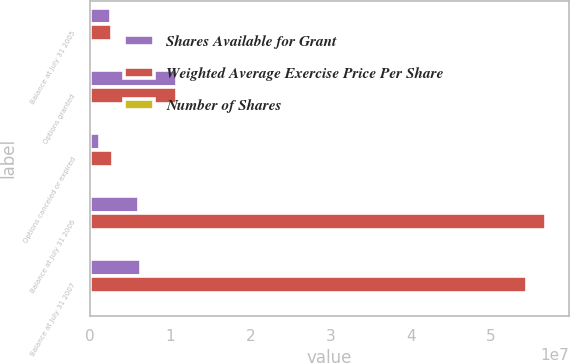<chart> <loc_0><loc_0><loc_500><loc_500><stacked_bar_chart><ecel><fcel>Balance at July 31 2005<fcel>Options granted<fcel>Options canceled or expired<fcel>Balance at July 31 2006<fcel>Balance at July 31 2007<nl><fcel>Shares Available for Grant<fcel>2.62638e+06<fcel>1.08161e+07<fcel>1.27059e+06<fcel>6.07209e+06<fcel>6.41046e+06<nl><fcel>Weighted Average Exercise Price Per Share<fcel>2.76661e+06<fcel>1.08161e+07<fcel>2.90684e+06<fcel>5.69315e+07<fcel>5.44896e+07<nl><fcel>Number of Shares<fcel>19.59<fcel>28.37<fcel>22.93<fcel>21.93<fcel>24.05<nl></chart> 